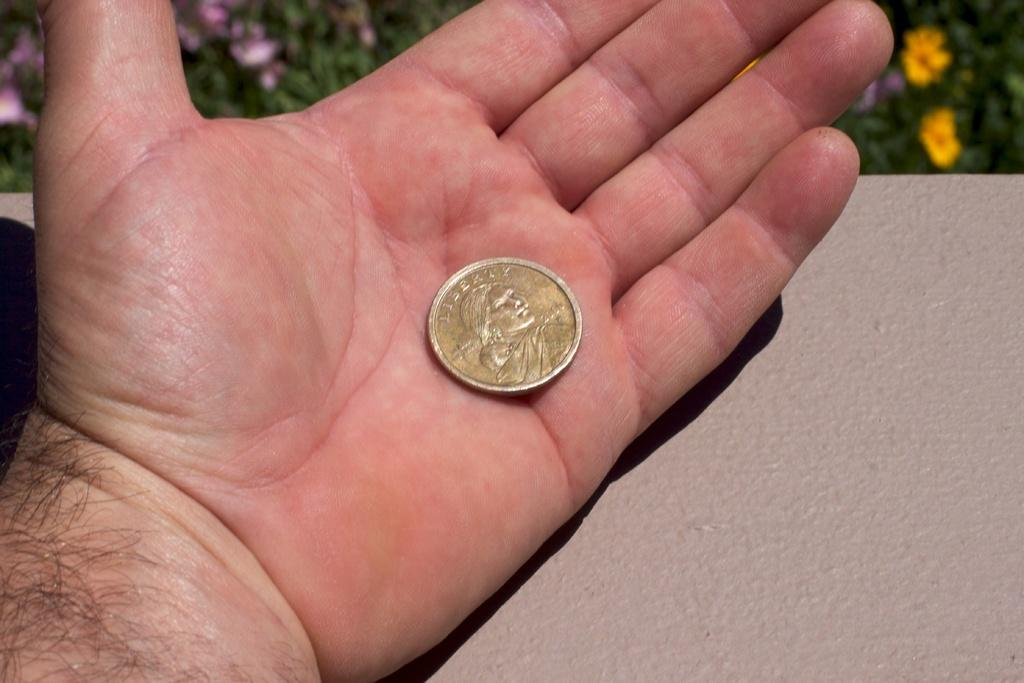Who or what is the main subject in the image? There is a person in the image. What is the person holding in their hand? The person is holding a liberty coin in their hand. Where is the hand with the coin placed? The hand with the coin is placed on a surface. What can be seen in the background of the image? There are flower plants in the background of the image. What type of button is being used to control the winter season in the image? There is no button or control for the winter season in the image. The image features a person holding a liberty coin with their hand placed on a surface, and flower plants in the background. 